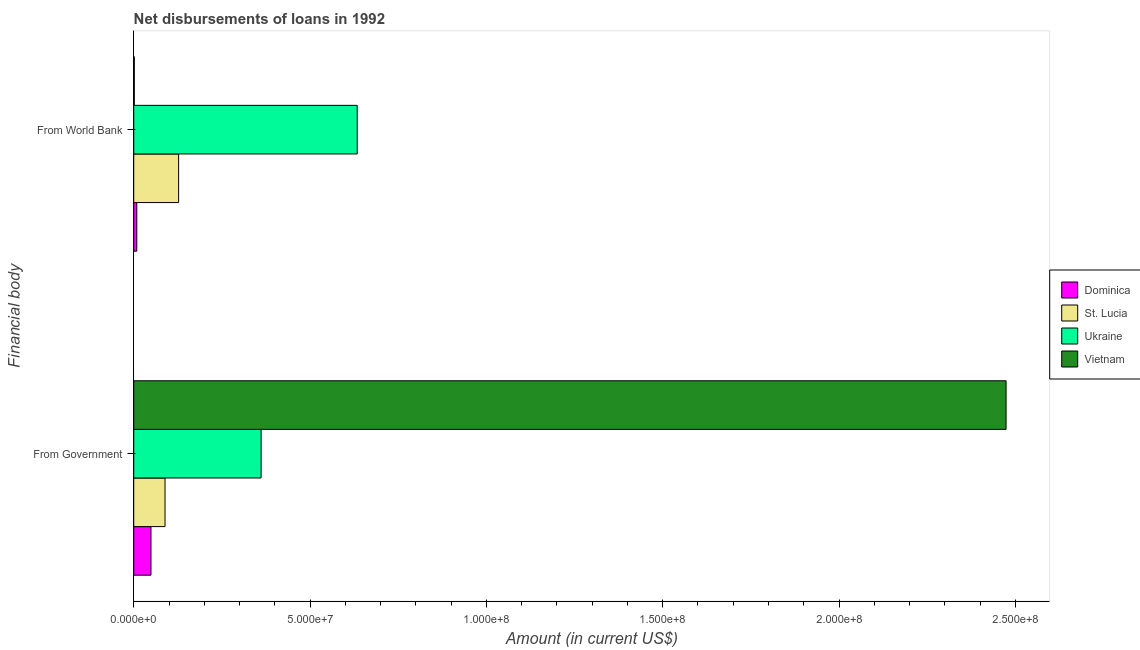How many different coloured bars are there?
Your answer should be compact. 4. How many groups of bars are there?
Your answer should be very brief. 2. Are the number of bars per tick equal to the number of legend labels?
Your answer should be very brief. Yes. How many bars are there on the 1st tick from the top?
Offer a very short reply. 4. How many bars are there on the 1st tick from the bottom?
Your response must be concise. 4. What is the label of the 2nd group of bars from the top?
Keep it short and to the point. From Government. What is the net disbursements of loan from world bank in Ukraine?
Provide a short and direct response. 6.34e+07. Across all countries, what is the maximum net disbursements of loan from government?
Your response must be concise. 2.47e+08. Across all countries, what is the minimum net disbursements of loan from world bank?
Provide a short and direct response. 1.58e+05. In which country was the net disbursements of loan from world bank maximum?
Make the answer very short. Ukraine. In which country was the net disbursements of loan from government minimum?
Keep it short and to the point. Dominica. What is the total net disbursements of loan from government in the graph?
Your answer should be very brief. 2.97e+08. What is the difference between the net disbursements of loan from world bank in St. Lucia and that in Vietnam?
Your response must be concise. 1.26e+07. What is the difference between the net disbursements of loan from world bank in Dominica and the net disbursements of loan from government in Vietnam?
Ensure brevity in your answer.  -2.47e+08. What is the average net disbursements of loan from government per country?
Offer a very short reply. 7.43e+07. What is the difference between the net disbursements of loan from government and net disbursements of loan from world bank in Ukraine?
Your answer should be compact. -2.73e+07. What is the ratio of the net disbursements of loan from government in St. Lucia to that in Dominica?
Make the answer very short. 1.82. In how many countries, is the net disbursements of loan from world bank greater than the average net disbursements of loan from world bank taken over all countries?
Make the answer very short. 1. What does the 2nd bar from the top in From Government represents?
Provide a short and direct response. Ukraine. What does the 2nd bar from the bottom in From Government represents?
Ensure brevity in your answer.  St. Lucia. How many bars are there?
Offer a terse response. 8. Does the graph contain any zero values?
Offer a very short reply. No. Does the graph contain grids?
Offer a very short reply. No. How many legend labels are there?
Ensure brevity in your answer.  4. What is the title of the graph?
Provide a succinct answer. Net disbursements of loans in 1992. What is the label or title of the Y-axis?
Provide a succinct answer. Financial body. What is the Amount (in current US$) in Dominica in From Government?
Your answer should be very brief. 4.89e+06. What is the Amount (in current US$) in St. Lucia in From Government?
Your answer should be compact. 8.88e+06. What is the Amount (in current US$) of Ukraine in From Government?
Offer a very short reply. 3.61e+07. What is the Amount (in current US$) in Vietnam in From Government?
Your answer should be compact. 2.47e+08. What is the Amount (in current US$) in Dominica in From World Bank?
Your answer should be very brief. 8.64e+05. What is the Amount (in current US$) in St. Lucia in From World Bank?
Your answer should be very brief. 1.27e+07. What is the Amount (in current US$) of Ukraine in From World Bank?
Your answer should be very brief. 6.34e+07. What is the Amount (in current US$) of Vietnam in From World Bank?
Offer a terse response. 1.58e+05. Across all Financial body, what is the maximum Amount (in current US$) of Dominica?
Provide a short and direct response. 4.89e+06. Across all Financial body, what is the maximum Amount (in current US$) in St. Lucia?
Your answer should be compact. 1.27e+07. Across all Financial body, what is the maximum Amount (in current US$) of Ukraine?
Offer a terse response. 6.34e+07. Across all Financial body, what is the maximum Amount (in current US$) of Vietnam?
Make the answer very short. 2.47e+08. Across all Financial body, what is the minimum Amount (in current US$) of Dominica?
Your answer should be very brief. 8.64e+05. Across all Financial body, what is the minimum Amount (in current US$) in St. Lucia?
Your response must be concise. 8.88e+06. Across all Financial body, what is the minimum Amount (in current US$) in Ukraine?
Offer a very short reply. 3.61e+07. Across all Financial body, what is the minimum Amount (in current US$) of Vietnam?
Offer a very short reply. 1.58e+05. What is the total Amount (in current US$) of Dominica in the graph?
Provide a succinct answer. 5.75e+06. What is the total Amount (in current US$) in St. Lucia in the graph?
Ensure brevity in your answer.  2.16e+07. What is the total Amount (in current US$) in Ukraine in the graph?
Your response must be concise. 9.95e+07. What is the total Amount (in current US$) of Vietnam in the graph?
Your response must be concise. 2.48e+08. What is the difference between the Amount (in current US$) in Dominica in From Government and that in From World Bank?
Give a very brief answer. 4.02e+06. What is the difference between the Amount (in current US$) of St. Lucia in From Government and that in From World Bank?
Make the answer very short. -3.85e+06. What is the difference between the Amount (in current US$) of Ukraine in From Government and that in From World Bank?
Offer a terse response. -2.73e+07. What is the difference between the Amount (in current US$) of Vietnam in From Government and that in From World Bank?
Provide a short and direct response. 2.47e+08. What is the difference between the Amount (in current US$) of Dominica in From Government and the Amount (in current US$) of St. Lucia in From World Bank?
Give a very brief answer. -7.84e+06. What is the difference between the Amount (in current US$) in Dominica in From Government and the Amount (in current US$) in Ukraine in From World Bank?
Give a very brief answer. -5.85e+07. What is the difference between the Amount (in current US$) of Dominica in From Government and the Amount (in current US$) of Vietnam in From World Bank?
Provide a short and direct response. 4.73e+06. What is the difference between the Amount (in current US$) of St. Lucia in From Government and the Amount (in current US$) of Ukraine in From World Bank?
Your answer should be compact. -5.45e+07. What is the difference between the Amount (in current US$) of St. Lucia in From Government and the Amount (in current US$) of Vietnam in From World Bank?
Give a very brief answer. 8.72e+06. What is the difference between the Amount (in current US$) in Ukraine in From Government and the Amount (in current US$) in Vietnam in From World Bank?
Provide a succinct answer. 3.60e+07. What is the average Amount (in current US$) of Dominica per Financial body?
Provide a short and direct response. 2.88e+06. What is the average Amount (in current US$) of St. Lucia per Financial body?
Keep it short and to the point. 1.08e+07. What is the average Amount (in current US$) in Ukraine per Financial body?
Keep it short and to the point. 4.97e+07. What is the average Amount (in current US$) in Vietnam per Financial body?
Make the answer very short. 1.24e+08. What is the difference between the Amount (in current US$) in Dominica and Amount (in current US$) in St. Lucia in From Government?
Provide a short and direct response. -3.99e+06. What is the difference between the Amount (in current US$) of Dominica and Amount (in current US$) of Ukraine in From Government?
Your answer should be compact. -3.12e+07. What is the difference between the Amount (in current US$) in Dominica and Amount (in current US$) in Vietnam in From Government?
Provide a short and direct response. -2.42e+08. What is the difference between the Amount (in current US$) in St. Lucia and Amount (in current US$) in Ukraine in From Government?
Ensure brevity in your answer.  -2.72e+07. What is the difference between the Amount (in current US$) in St. Lucia and Amount (in current US$) in Vietnam in From Government?
Give a very brief answer. -2.39e+08. What is the difference between the Amount (in current US$) in Ukraine and Amount (in current US$) in Vietnam in From Government?
Offer a terse response. -2.11e+08. What is the difference between the Amount (in current US$) in Dominica and Amount (in current US$) in St. Lucia in From World Bank?
Give a very brief answer. -1.19e+07. What is the difference between the Amount (in current US$) of Dominica and Amount (in current US$) of Ukraine in From World Bank?
Offer a terse response. -6.25e+07. What is the difference between the Amount (in current US$) of Dominica and Amount (in current US$) of Vietnam in From World Bank?
Offer a terse response. 7.06e+05. What is the difference between the Amount (in current US$) of St. Lucia and Amount (in current US$) of Ukraine in From World Bank?
Offer a terse response. -5.07e+07. What is the difference between the Amount (in current US$) of St. Lucia and Amount (in current US$) of Vietnam in From World Bank?
Your answer should be compact. 1.26e+07. What is the difference between the Amount (in current US$) in Ukraine and Amount (in current US$) in Vietnam in From World Bank?
Offer a terse response. 6.32e+07. What is the ratio of the Amount (in current US$) of Dominica in From Government to that in From World Bank?
Your answer should be compact. 5.66. What is the ratio of the Amount (in current US$) of St. Lucia in From Government to that in From World Bank?
Give a very brief answer. 0.7. What is the ratio of the Amount (in current US$) of Ukraine in From Government to that in From World Bank?
Your answer should be compact. 0.57. What is the ratio of the Amount (in current US$) in Vietnam in From Government to that in From World Bank?
Give a very brief answer. 1565.7. What is the difference between the highest and the second highest Amount (in current US$) in Dominica?
Ensure brevity in your answer.  4.02e+06. What is the difference between the highest and the second highest Amount (in current US$) in St. Lucia?
Provide a succinct answer. 3.85e+06. What is the difference between the highest and the second highest Amount (in current US$) in Ukraine?
Provide a succinct answer. 2.73e+07. What is the difference between the highest and the second highest Amount (in current US$) of Vietnam?
Give a very brief answer. 2.47e+08. What is the difference between the highest and the lowest Amount (in current US$) of Dominica?
Keep it short and to the point. 4.02e+06. What is the difference between the highest and the lowest Amount (in current US$) of St. Lucia?
Ensure brevity in your answer.  3.85e+06. What is the difference between the highest and the lowest Amount (in current US$) of Ukraine?
Your answer should be very brief. 2.73e+07. What is the difference between the highest and the lowest Amount (in current US$) of Vietnam?
Provide a short and direct response. 2.47e+08. 